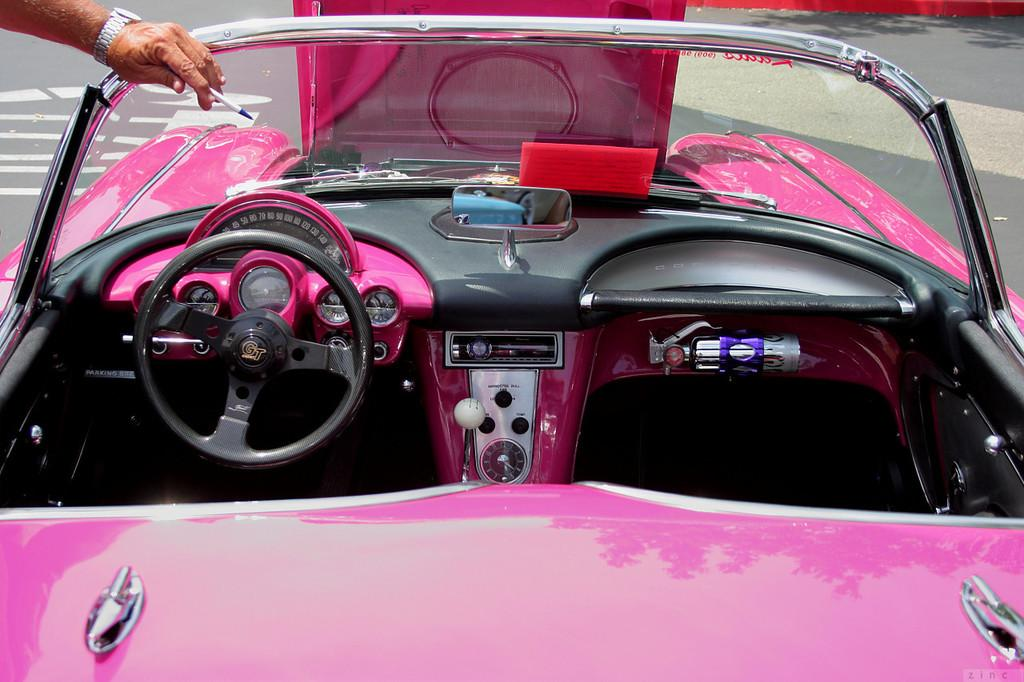What color is the vehicle in the image? The vehicle in the image is pink. What feature is present in the vehicle for controlling its direction? The vehicle has a steering wheel. What can be found inside the vehicle besides the steering wheel? There are other objects inside the vehicle. Can you describe the person in the image? There is a person in the left top corner of the image, and he has placed his hand on the vehicle. What type of goose is cooking on the stove inside the vehicle? There is no goose or stove present inside the vehicle; it only contains a pink vehicle and other objects. How many wheels does the wheel have in the image? The question is unclear and seems to be referring to the vehicle's wheels, which are not specified as having any additional wheels. The vehicle has standard wheels for its type. 